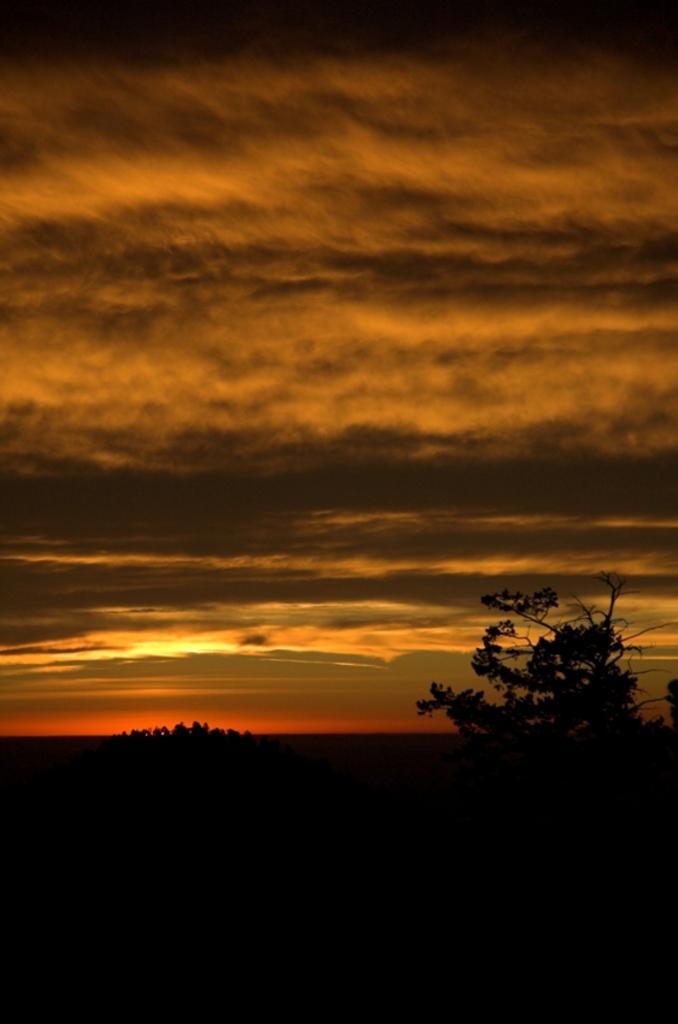How would you summarize this image in a sentence or two? In this image we can see trees. In the back there is sky with clouds. And the image is looking dark. 